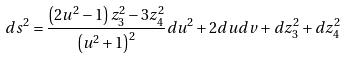Convert formula to latex. <formula><loc_0><loc_0><loc_500><loc_500>d s ^ { 2 } = \frac { \left ( 2 u ^ { 2 } - 1 \right ) z _ { 3 } ^ { 2 } - 3 z _ { 4 } ^ { 2 } } { \left ( u ^ { 2 } + 1 \right ) ^ { 2 } } d u ^ { 2 } + 2 d u d v + d z _ { 3 } ^ { 2 } + d z _ { 4 } ^ { 2 }</formula> 